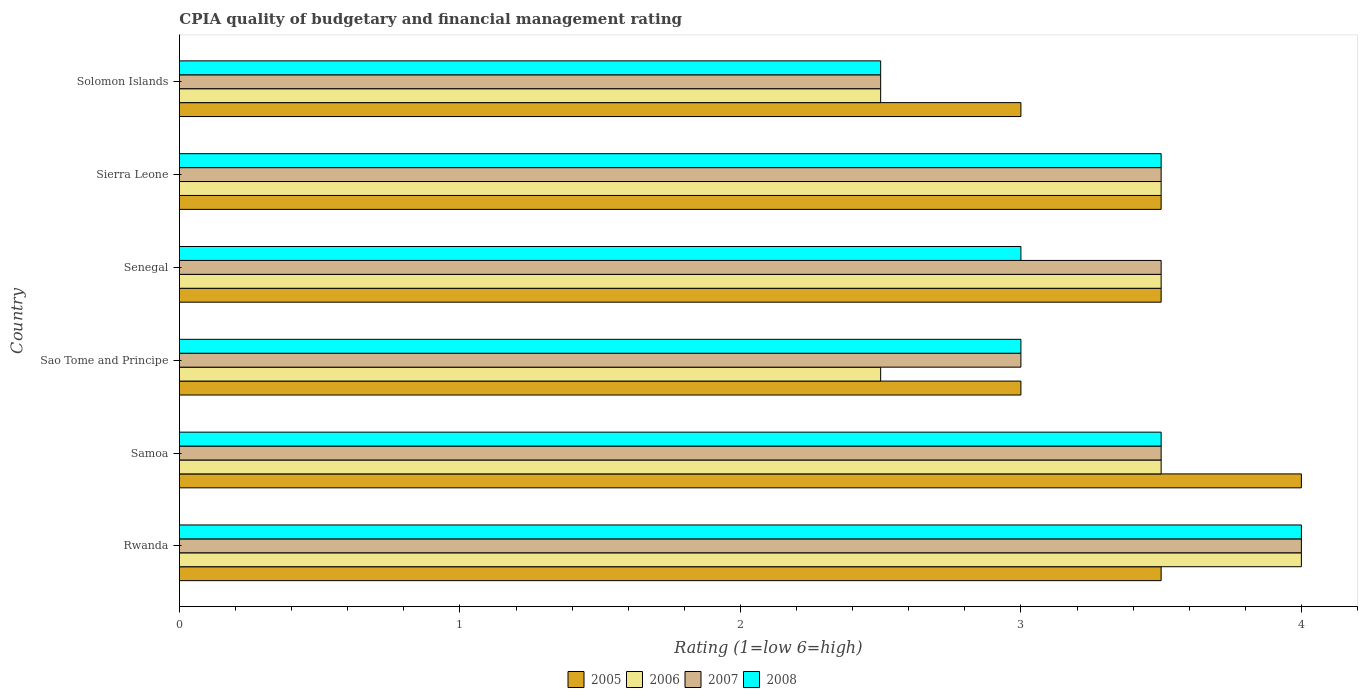How many different coloured bars are there?
Keep it short and to the point. 4. Are the number of bars on each tick of the Y-axis equal?
Your answer should be very brief. Yes. How many bars are there on the 4th tick from the bottom?
Ensure brevity in your answer.  4. What is the label of the 5th group of bars from the top?
Make the answer very short. Samoa. What is the CPIA rating in 2008 in Rwanda?
Offer a terse response. 4. Across all countries, what is the minimum CPIA rating in 2005?
Give a very brief answer. 3. In which country was the CPIA rating in 2005 maximum?
Your answer should be very brief. Samoa. In which country was the CPIA rating in 2007 minimum?
Offer a terse response. Solomon Islands. What is the difference between the CPIA rating in 2007 in Sao Tome and Principe and that in Senegal?
Offer a terse response. -0.5. What is the difference between the CPIA rating in 2008 in Sierra Leone and the CPIA rating in 2006 in Samoa?
Your answer should be very brief. 0. What is the average CPIA rating in 2007 per country?
Offer a terse response. 3.33. What is the difference between the CPIA rating in 2006 and CPIA rating in 2005 in Rwanda?
Make the answer very short. 0.5. What is the ratio of the CPIA rating in 2008 in Samoa to that in Sao Tome and Principe?
Keep it short and to the point. 1.17. Is the CPIA rating in 2006 in Rwanda less than that in Samoa?
Provide a short and direct response. No. In how many countries, is the CPIA rating in 2007 greater than the average CPIA rating in 2007 taken over all countries?
Offer a terse response. 4. Is the sum of the CPIA rating in 2005 in Senegal and Sierra Leone greater than the maximum CPIA rating in 2007 across all countries?
Make the answer very short. Yes. What does the 1st bar from the top in Senegal represents?
Offer a very short reply. 2008. What does the 2nd bar from the bottom in Rwanda represents?
Your response must be concise. 2006. How many bars are there?
Make the answer very short. 24. Are all the bars in the graph horizontal?
Keep it short and to the point. Yes. How many countries are there in the graph?
Keep it short and to the point. 6. What is the difference between two consecutive major ticks on the X-axis?
Your response must be concise. 1. Are the values on the major ticks of X-axis written in scientific E-notation?
Offer a very short reply. No. Where does the legend appear in the graph?
Make the answer very short. Bottom center. How many legend labels are there?
Provide a succinct answer. 4. What is the title of the graph?
Make the answer very short. CPIA quality of budgetary and financial management rating. What is the label or title of the Y-axis?
Provide a succinct answer. Country. What is the Rating (1=low 6=high) of 2005 in Rwanda?
Offer a very short reply. 3.5. What is the Rating (1=low 6=high) of 2006 in Rwanda?
Make the answer very short. 4. What is the Rating (1=low 6=high) of 2007 in Rwanda?
Your response must be concise. 4. What is the Rating (1=low 6=high) in 2006 in Samoa?
Provide a succinct answer. 3.5. What is the Rating (1=low 6=high) in 2008 in Samoa?
Offer a terse response. 3.5. What is the Rating (1=low 6=high) in 2006 in Sao Tome and Principe?
Your answer should be very brief. 2.5. What is the Rating (1=low 6=high) in 2008 in Sao Tome and Principe?
Your answer should be compact. 3. What is the Rating (1=low 6=high) in 2005 in Senegal?
Make the answer very short. 3.5. What is the Rating (1=low 6=high) in 2006 in Senegal?
Provide a short and direct response. 3.5. What is the Rating (1=low 6=high) of 2007 in Senegal?
Make the answer very short. 3.5. What is the Rating (1=low 6=high) of 2006 in Sierra Leone?
Your answer should be very brief. 3.5. What is the Rating (1=low 6=high) of 2007 in Sierra Leone?
Make the answer very short. 3.5. What is the Rating (1=low 6=high) in 2008 in Sierra Leone?
Ensure brevity in your answer.  3.5. What is the Rating (1=low 6=high) in 2007 in Solomon Islands?
Make the answer very short. 2.5. Across all countries, what is the maximum Rating (1=low 6=high) of 2005?
Provide a short and direct response. 4. Across all countries, what is the maximum Rating (1=low 6=high) of 2006?
Provide a succinct answer. 4. Across all countries, what is the minimum Rating (1=low 6=high) in 2005?
Your answer should be very brief. 3. Across all countries, what is the minimum Rating (1=low 6=high) of 2006?
Provide a succinct answer. 2.5. Across all countries, what is the minimum Rating (1=low 6=high) in 2007?
Make the answer very short. 2.5. What is the total Rating (1=low 6=high) in 2007 in the graph?
Provide a short and direct response. 20. What is the difference between the Rating (1=low 6=high) of 2006 in Rwanda and that in Samoa?
Provide a short and direct response. 0.5. What is the difference between the Rating (1=low 6=high) of 2006 in Rwanda and that in Sao Tome and Principe?
Your response must be concise. 1.5. What is the difference between the Rating (1=low 6=high) in 2007 in Rwanda and that in Sao Tome and Principe?
Your answer should be compact. 1. What is the difference between the Rating (1=low 6=high) in 2008 in Rwanda and that in Sao Tome and Principe?
Offer a terse response. 1. What is the difference between the Rating (1=low 6=high) in 2006 in Rwanda and that in Senegal?
Your answer should be very brief. 0.5. What is the difference between the Rating (1=low 6=high) of 2005 in Rwanda and that in Sierra Leone?
Ensure brevity in your answer.  0. What is the difference between the Rating (1=low 6=high) in 2006 in Rwanda and that in Solomon Islands?
Your answer should be compact. 1.5. What is the difference between the Rating (1=low 6=high) in 2008 in Rwanda and that in Solomon Islands?
Ensure brevity in your answer.  1.5. What is the difference between the Rating (1=low 6=high) of 2005 in Samoa and that in Sao Tome and Principe?
Give a very brief answer. 1. What is the difference between the Rating (1=low 6=high) of 2006 in Samoa and that in Sao Tome and Principe?
Offer a very short reply. 1. What is the difference between the Rating (1=low 6=high) of 2008 in Samoa and that in Sao Tome and Principe?
Ensure brevity in your answer.  0.5. What is the difference between the Rating (1=low 6=high) in 2008 in Samoa and that in Senegal?
Your answer should be compact. 0.5. What is the difference between the Rating (1=low 6=high) in 2005 in Samoa and that in Sierra Leone?
Offer a terse response. 0.5. What is the difference between the Rating (1=low 6=high) in 2006 in Samoa and that in Sierra Leone?
Your answer should be very brief. 0. What is the difference between the Rating (1=low 6=high) of 2008 in Samoa and that in Sierra Leone?
Offer a terse response. 0. What is the difference between the Rating (1=low 6=high) in 2005 in Samoa and that in Solomon Islands?
Give a very brief answer. 1. What is the difference between the Rating (1=low 6=high) of 2006 in Samoa and that in Solomon Islands?
Provide a succinct answer. 1. What is the difference between the Rating (1=low 6=high) in 2007 in Samoa and that in Solomon Islands?
Your response must be concise. 1. What is the difference between the Rating (1=low 6=high) in 2008 in Samoa and that in Solomon Islands?
Give a very brief answer. 1. What is the difference between the Rating (1=low 6=high) of 2005 in Sao Tome and Principe and that in Senegal?
Keep it short and to the point. -0.5. What is the difference between the Rating (1=low 6=high) of 2007 in Sao Tome and Principe and that in Senegal?
Your answer should be very brief. -0.5. What is the difference between the Rating (1=low 6=high) in 2006 in Sao Tome and Principe and that in Sierra Leone?
Offer a terse response. -1. What is the difference between the Rating (1=low 6=high) of 2007 in Sao Tome and Principe and that in Sierra Leone?
Provide a short and direct response. -0.5. What is the difference between the Rating (1=low 6=high) in 2008 in Sao Tome and Principe and that in Sierra Leone?
Your response must be concise. -0.5. What is the difference between the Rating (1=low 6=high) in 2005 in Sao Tome and Principe and that in Solomon Islands?
Ensure brevity in your answer.  0. What is the difference between the Rating (1=low 6=high) of 2008 in Sao Tome and Principe and that in Solomon Islands?
Make the answer very short. 0.5. What is the difference between the Rating (1=low 6=high) in 2005 in Senegal and that in Sierra Leone?
Your answer should be very brief. 0. What is the difference between the Rating (1=low 6=high) in 2007 in Senegal and that in Sierra Leone?
Offer a terse response. 0. What is the difference between the Rating (1=low 6=high) of 2005 in Senegal and that in Solomon Islands?
Provide a succinct answer. 0.5. What is the difference between the Rating (1=low 6=high) of 2005 in Rwanda and the Rating (1=low 6=high) of 2007 in Samoa?
Your response must be concise. 0. What is the difference between the Rating (1=low 6=high) in 2006 in Rwanda and the Rating (1=low 6=high) in 2007 in Samoa?
Provide a short and direct response. 0.5. What is the difference between the Rating (1=low 6=high) in 2007 in Rwanda and the Rating (1=low 6=high) in 2008 in Samoa?
Offer a terse response. 0.5. What is the difference between the Rating (1=low 6=high) in 2005 in Rwanda and the Rating (1=low 6=high) in 2006 in Sao Tome and Principe?
Make the answer very short. 1. What is the difference between the Rating (1=low 6=high) of 2006 in Rwanda and the Rating (1=low 6=high) of 2008 in Senegal?
Make the answer very short. 1. What is the difference between the Rating (1=low 6=high) in 2007 in Rwanda and the Rating (1=low 6=high) in 2008 in Senegal?
Provide a short and direct response. 1. What is the difference between the Rating (1=low 6=high) of 2005 in Rwanda and the Rating (1=low 6=high) of 2006 in Sierra Leone?
Make the answer very short. 0. What is the difference between the Rating (1=low 6=high) in 2006 in Rwanda and the Rating (1=low 6=high) in 2007 in Sierra Leone?
Offer a terse response. 0.5. What is the difference between the Rating (1=low 6=high) of 2007 in Rwanda and the Rating (1=low 6=high) of 2008 in Sierra Leone?
Your answer should be very brief. 0.5. What is the difference between the Rating (1=low 6=high) of 2005 in Rwanda and the Rating (1=low 6=high) of 2006 in Solomon Islands?
Make the answer very short. 1. What is the difference between the Rating (1=low 6=high) of 2005 in Rwanda and the Rating (1=low 6=high) of 2007 in Solomon Islands?
Give a very brief answer. 1. What is the difference between the Rating (1=low 6=high) in 2006 in Rwanda and the Rating (1=low 6=high) in 2008 in Solomon Islands?
Offer a very short reply. 1.5. What is the difference between the Rating (1=low 6=high) in 2007 in Rwanda and the Rating (1=low 6=high) in 2008 in Solomon Islands?
Provide a succinct answer. 1.5. What is the difference between the Rating (1=low 6=high) in 2005 in Samoa and the Rating (1=low 6=high) in 2008 in Sao Tome and Principe?
Provide a succinct answer. 1. What is the difference between the Rating (1=low 6=high) of 2007 in Samoa and the Rating (1=low 6=high) of 2008 in Sao Tome and Principe?
Your response must be concise. 0.5. What is the difference between the Rating (1=low 6=high) in 2005 in Samoa and the Rating (1=low 6=high) in 2007 in Senegal?
Provide a succinct answer. 0.5. What is the difference between the Rating (1=low 6=high) in 2006 in Samoa and the Rating (1=low 6=high) in 2007 in Senegal?
Make the answer very short. 0. What is the difference between the Rating (1=low 6=high) of 2007 in Samoa and the Rating (1=low 6=high) of 2008 in Senegal?
Your answer should be compact. 0.5. What is the difference between the Rating (1=low 6=high) in 2005 in Samoa and the Rating (1=low 6=high) in 2006 in Sierra Leone?
Your answer should be very brief. 0.5. What is the difference between the Rating (1=low 6=high) in 2006 in Samoa and the Rating (1=low 6=high) in 2007 in Sierra Leone?
Your answer should be compact. 0. What is the difference between the Rating (1=low 6=high) in 2005 in Samoa and the Rating (1=low 6=high) in 2007 in Solomon Islands?
Offer a very short reply. 1.5. What is the difference between the Rating (1=low 6=high) of 2006 in Samoa and the Rating (1=low 6=high) of 2007 in Solomon Islands?
Offer a very short reply. 1. What is the difference between the Rating (1=low 6=high) in 2007 in Samoa and the Rating (1=low 6=high) in 2008 in Solomon Islands?
Give a very brief answer. 1. What is the difference between the Rating (1=low 6=high) in 2005 in Sao Tome and Principe and the Rating (1=low 6=high) in 2007 in Senegal?
Give a very brief answer. -0.5. What is the difference between the Rating (1=low 6=high) of 2005 in Sao Tome and Principe and the Rating (1=low 6=high) of 2008 in Senegal?
Keep it short and to the point. 0. What is the difference between the Rating (1=low 6=high) of 2006 in Sao Tome and Principe and the Rating (1=low 6=high) of 2007 in Senegal?
Offer a terse response. -1. What is the difference between the Rating (1=low 6=high) in 2006 in Sao Tome and Principe and the Rating (1=low 6=high) in 2008 in Senegal?
Keep it short and to the point. -0.5. What is the difference between the Rating (1=low 6=high) in 2007 in Sao Tome and Principe and the Rating (1=low 6=high) in 2008 in Senegal?
Offer a terse response. 0. What is the difference between the Rating (1=low 6=high) of 2005 in Sao Tome and Principe and the Rating (1=low 6=high) of 2007 in Sierra Leone?
Your response must be concise. -0.5. What is the difference between the Rating (1=low 6=high) in 2005 in Sao Tome and Principe and the Rating (1=low 6=high) in 2008 in Sierra Leone?
Your answer should be very brief. -0.5. What is the difference between the Rating (1=low 6=high) in 2006 in Sao Tome and Principe and the Rating (1=low 6=high) in 2008 in Sierra Leone?
Keep it short and to the point. -1. What is the difference between the Rating (1=low 6=high) of 2007 in Sao Tome and Principe and the Rating (1=low 6=high) of 2008 in Sierra Leone?
Offer a very short reply. -0.5. What is the difference between the Rating (1=low 6=high) in 2005 in Sao Tome and Principe and the Rating (1=low 6=high) in 2007 in Solomon Islands?
Offer a terse response. 0.5. What is the difference between the Rating (1=low 6=high) in 2006 in Sao Tome and Principe and the Rating (1=low 6=high) in 2007 in Solomon Islands?
Make the answer very short. 0. What is the difference between the Rating (1=low 6=high) of 2005 in Senegal and the Rating (1=low 6=high) of 2006 in Sierra Leone?
Keep it short and to the point. 0. What is the difference between the Rating (1=low 6=high) of 2006 in Senegal and the Rating (1=low 6=high) of 2008 in Sierra Leone?
Provide a short and direct response. 0. What is the difference between the Rating (1=low 6=high) in 2005 in Senegal and the Rating (1=low 6=high) in 2008 in Solomon Islands?
Give a very brief answer. 1. What is the difference between the Rating (1=low 6=high) of 2006 in Senegal and the Rating (1=low 6=high) of 2007 in Solomon Islands?
Your response must be concise. 1. What is the difference between the Rating (1=low 6=high) of 2006 in Senegal and the Rating (1=low 6=high) of 2008 in Solomon Islands?
Keep it short and to the point. 1. What is the difference between the Rating (1=low 6=high) of 2005 in Sierra Leone and the Rating (1=low 6=high) of 2008 in Solomon Islands?
Provide a succinct answer. 1. What is the difference between the Rating (1=low 6=high) of 2006 in Sierra Leone and the Rating (1=low 6=high) of 2007 in Solomon Islands?
Your answer should be compact. 1. What is the difference between the Rating (1=low 6=high) in 2007 in Sierra Leone and the Rating (1=low 6=high) in 2008 in Solomon Islands?
Ensure brevity in your answer.  1. What is the average Rating (1=low 6=high) in 2005 per country?
Provide a short and direct response. 3.42. What is the average Rating (1=low 6=high) of 2007 per country?
Ensure brevity in your answer.  3.33. What is the average Rating (1=low 6=high) of 2008 per country?
Ensure brevity in your answer.  3.25. What is the difference between the Rating (1=low 6=high) of 2005 and Rating (1=low 6=high) of 2008 in Rwanda?
Make the answer very short. -0.5. What is the difference between the Rating (1=low 6=high) in 2007 and Rating (1=low 6=high) in 2008 in Rwanda?
Provide a short and direct response. 0. What is the difference between the Rating (1=low 6=high) in 2005 and Rating (1=low 6=high) in 2007 in Samoa?
Ensure brevity in your answer.  0.5. What is the difference between the Rating (1=low 6=high) of 2005 and Rating (1=low 6=high) of 2008 in Samoa?
Your response must be concise. 0.5. What is the difference between the Rating (1=low 6=high) of 2005 and Rating (1=low 6=high) of 2007 in Sao Tome and Principe?
Make the answer very short. 0. What is the difference between the Rating (1=low 6=high) of 2006 and Rating (1=low 6=high) of 2007 in Sao Tome and Principe?
Your response must be concise. -0.5. What is the difference between the Rating (1=low 6=high) in 2005 and Rating (1=low 6=high) in 2007 in Senegal?
Make the answer very short. 0. What is the difference between the Rating (1=low 6=high) of 2006 and Rating (1=low 6=high) of 2008 in Senegal?
Your answer should be compact. 0.5. What is the difference between the Rating (1=low 6=high) of 2005 and Rating (1=low 6=high) of 2006 in Sierra Leone?
Make the answer very short. 0. What is the difference between the Rating (1=low 6=high) in 2005 and Rating (1=low 6=high) in 2008 in Sierra Leone?
Provide a short and direct response. 0. What is the difference between the Rating (1=low 6=high) of 2006 and Rating (1=low 6=high) of 2007 in Sierra Leone?
Offer a terse response. 0. What is the difference between the Rating (1=low 6=high) of 2005 and Rating (1=low 6=high) of 2008 in Solomon Islands?
Your answer should be compact. 0.5. What is the difference between the Rating (1=low 6=high) in 2006 and Rating (1=low 6=high) in 2007 in Solomon Islands?
Your answer should be very brief. 0. What is the difference between the Rating (1=low 6=high) in 2007 and Rating (1=low 6=high) in 2008 in Solomon Islands?
Provide a short and direct response. 0. What is the ratio of the Rating (1=low 6=high) of 2005 in Rwanda to that in Samoa?
Give a very brief answer. 0.88. What is the ratio of the Rating (1=low 6=high) of 2006 in Rwanda to that in Samoa?
Keep it short and to the point. 1.14. What is the ratio of the Rating (1=low 6=high) of 2005 in Rwanda to that in Sao Tome and Principe?
Offer a very short reply. 1.17. What is the ratio of the Rating (1=low 6=high) in 2006 in Rwanda to that in Sao Tome and Principe?
Offer a very short reply. 1.6. What is the ratio of the Rating (1=low 6=high) of 2007 in Rwanda to that in Sao Tome and Principe?
Keep it short and to the point. 1.33. What is the ratio of the Rating (1=low 6=high) in 2008 in Rwanda to that in Sao Tome and Principe?
Your answer should be very brief. 1.33. What is the ratio of the Rating (1=low 6=high) in 2005 in Rwanda to that in Senegal?
Ensure brevity in your answer.  1. What is the ratio of the Rating (1=low 6=high) in 2006 in Rwanda to that in Senegal?
Your answer should be very brief. 1.14. What is the ratio of the Rating (1=low 6=high) in 2007 in Rwanda to that in Senegal?
Ensure brevity in your answer.  1.14. What is the ratio of the Rating (1=low 6=high) of 2008 in Rwanda to that in Senegal?
Ensure brevity in your answer.  1.33. What is the ratio of the Rating (1=low 6=high) of 2005 in Rwanda to that in Sierra Leone?
Your answer should be compact. 1. What is the ratio of the Rating (1=low 6=high) of 2008 in Rwanda to that in Sierra Leone?
Offer a terse response. 1.14. What is the ratio of the Rating (1=low 6=high) in 2005 in Rwanda to that in Solomon Islands?
Your answer should be very brief. 1.17. What is the ratio of the Rating (1=low 6=high) in 2006 in Rwanda to that in Solomon Islands?
Your answer should be very brief. 1.6. What is the ratio of the Rating (1=low 6=high) of 2007 in Rwanda to that in Solomon Islands?
Your answer should be compact. 1.6. What is the ratio of the Rating (1=low 6=high) of 2008 in Rwanda to that in Solomon Islands?
Offer a terse response. 1.6. What is the ratio of the Rating (1=low 6=high) in 2007 in Samoa to that in Sao Tome and Principe?
Offer a terse response. 1.17. What is the ratio of the Rating (1=low 6=high) of 2005 in Samoa to that in Senegal?
Make the answer very short. 1.14. What is the ratio of the Rating (1=low 6=high) of 2006 in Samoa to that in Senegal?
Offer a terse response. 1. What is the ratio of the Rating (1=low 6=high) in 2007 in Samoa to that in Senegal?
Offer a very short reply. 1. What is the ratio of the Rating (1=low 6=high) in 2008 in Samoa to that in Senegal?
Your response must be concise. 1.17. What is the ratio of the Rating (1=low 6=high) in 2005 in Samoa to that in Sierra Leone?
Make the answer very short. 1.14. What is the ratio of the Rating (1=low 6=high) of 2005 in Samoa to that in Solomon Islands?
Ensure brevity in your answer.  1.33. What is the ratio of the Rating (1=low 6=high) in 2006 in Samoa to that in Solomon Islands?
Provide a succinct answer. 1.4. What is the ratio of the Rating (1=low 6=high) of 2007 in Samoa to that in Solomon Islands?
Offer a terse response. 1.4. What is the ratio of the Rating (1=low 6=high) of 2006 in Sao Tome and Principe to that in Sierra Leone?
Your answer should be compact. 0.71. What is the ratio of the Rating (1=low 6=high) in 2008 in Sao Tome and Principe to that in Sierra Leone?
Provide a succinct answer. 0.86. What is the ratio of the Rating (1=low 6=high) of 2008 in Sao Tome and Principe to that in Solomon Islands?
Give a very brief answer. 1.2. What is the ratio of the Rating (1=low 6=high) of 2005 in Senegal to that in Sierra Leone?
Ensure brevity in your answer.  1. What is the ratio of the Rating (1=low 6=high) in 2006 in Senegal to that in Sierra Leone?
Your answer should be very brief. 1. What is the ratio of the Rating (1=low 6=high) of 2008 in Senegal to that in Sierra Leone?
Offer a very short reply. 0.86. What is the ratio of the Rating (1=low 6=high) in 2007 in Senegal to that in Solomon Islands?
Provide a short and direct response. 1.4. What is the ratio of the Rating (1=low 6=high) of 2008 in Senegal to that in Solomon Islands?
Keep it short and to the point. 1.2. What is the ratio of the Rating (1=low 6=high) in 2005 in Sierra Leone to that in Solomon Islands?
Make the answer very short. 1.17. What is the ratio of the Rating (1=low 6=high) in 2006 in Sierra Leone to that in Solomon Islands?
Make the answer very short. 1.4. What is the difference between the highest and the second highest Rating (1=low 6=high) in 2006?
Make the answer very short. 0.5. What is the difference between the highest and the lowest Rating (1=low 6=high) in 2005?
Provide a succinct answer. 1. What is the difference between the highest and the lowest Rating (1=low 6=high) of 2007?
Keep it short and to the point. 1.5. What is the difference between the highest and the lowest Rating (1=low 6=high) in 2008?
Your answer should be compact. 1.5. 